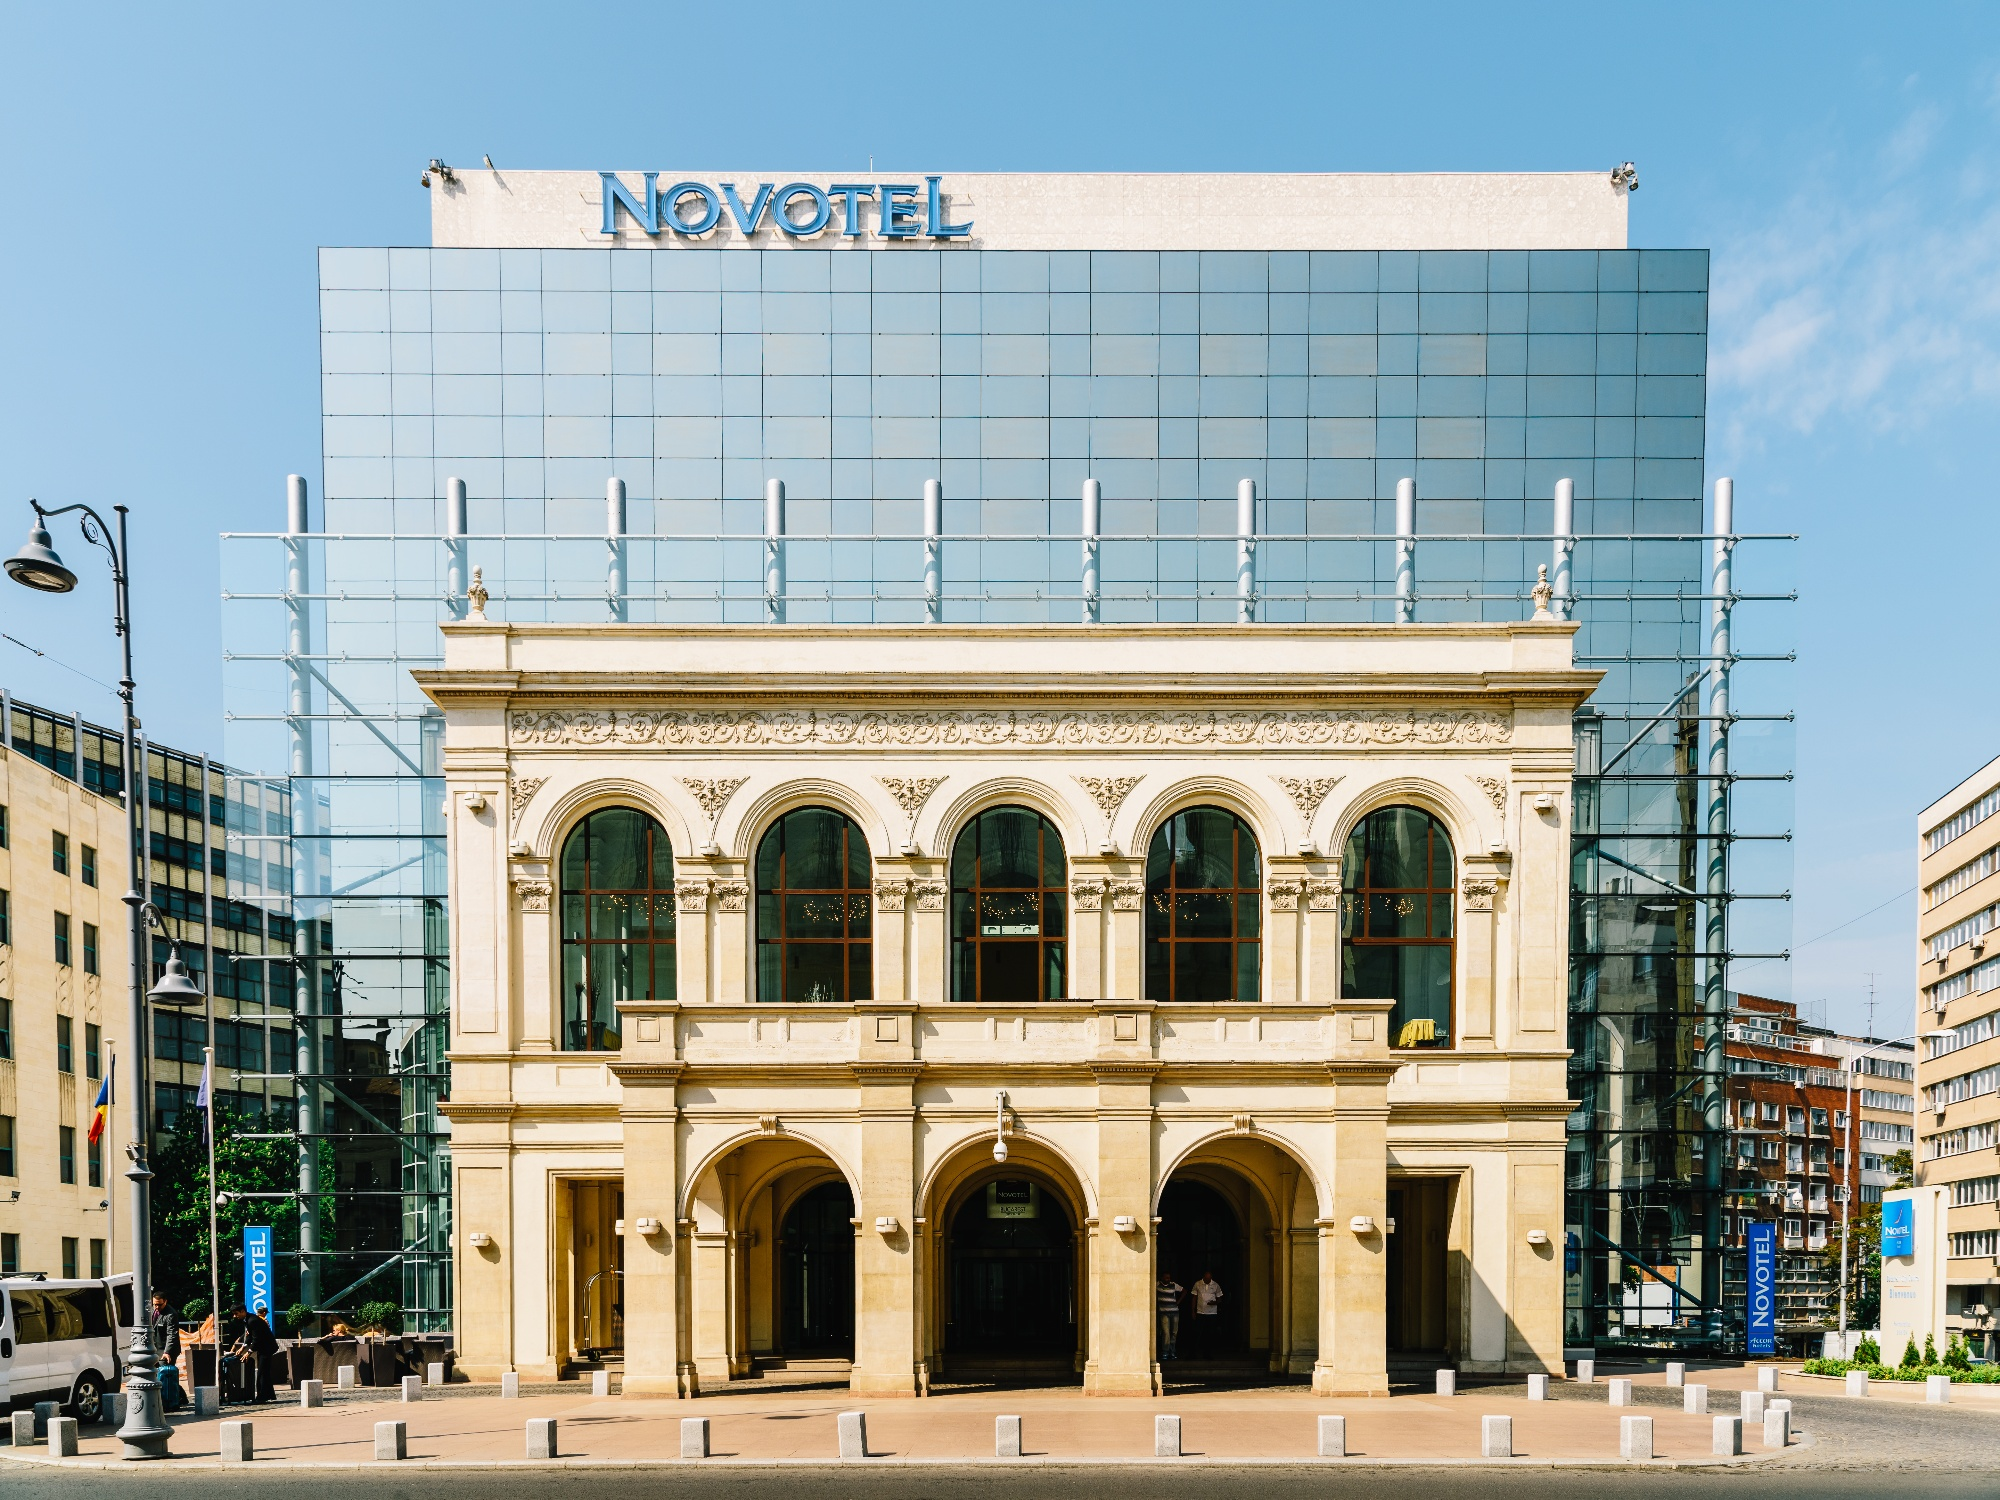Can you tell me about the activities typically occurring around this area in Warsaw? The area surrounding the Novotel Hotel in Warsaw tends to be bustling with activity. Given its central location, you would typically observe a mix of tourists and locals engaging with the area. Nearby, restaurants, shops, and cafes attract a vibrant crowd. The presence of pedestrians and parked vehicles in the image suggests it is a well-frequented area, likely close to business centers and cultural hubs, making it a focal point for both leisure and commerce. 